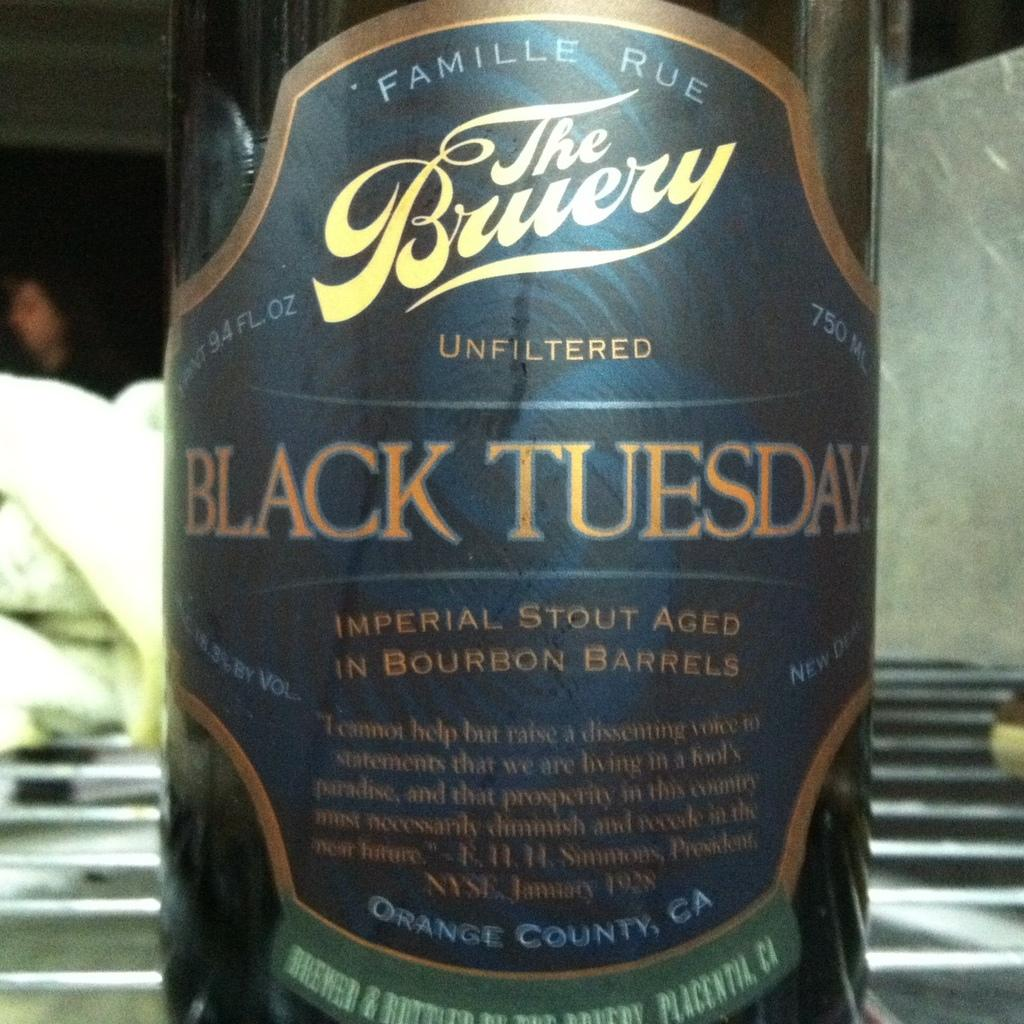<image>
Create a compact narrative representing the image presented. A bottle of Black Tuesday imperial stout sits on a table. 